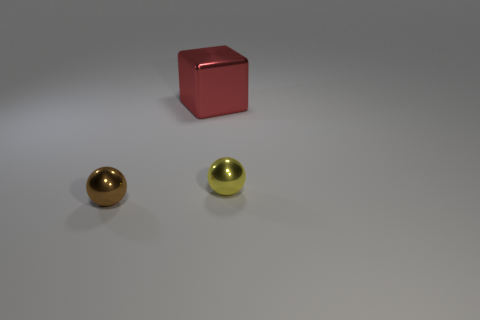Is the number of large red objects behind the red object greater than the number of tiny shiny cylinders? no 